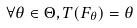<formula> <loc_0><loc_0><loc_500><loc_500>\forall \theta \in \Theta , T ( F _ { \theta } ) = \theta</formula> 